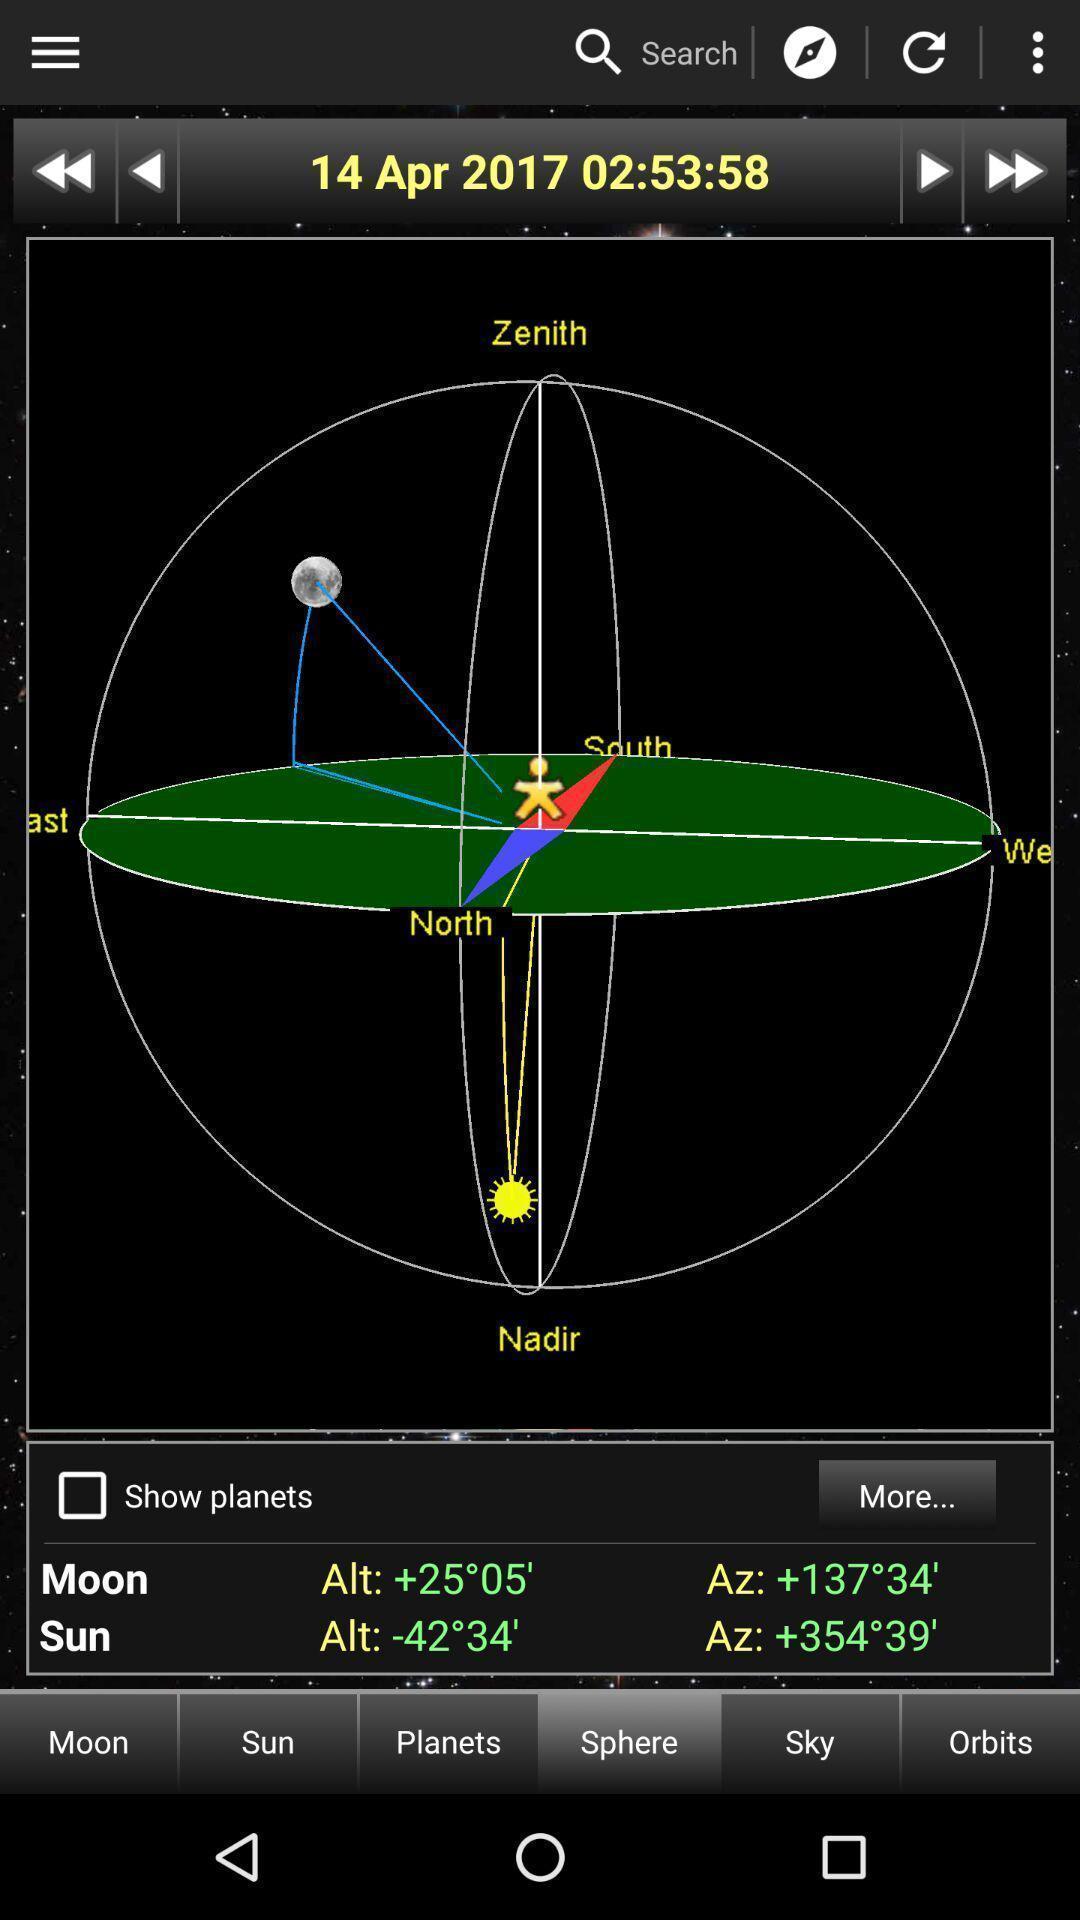What is the overall content of this screenshot? Page showing the locations of sun and moon. 